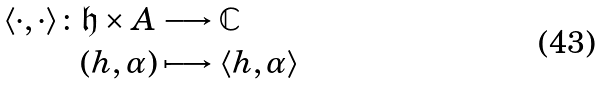<formula> <loc_0><loc_0><loc_500><loc_500>\langle \cdot , \cdot \rangle \colon \mathfrak { h } \times A & \longrightarrow \mathbb { C } \\ ( h , \alpha ) & \longmapsto \langle h , \alpha \rangle</formula> 